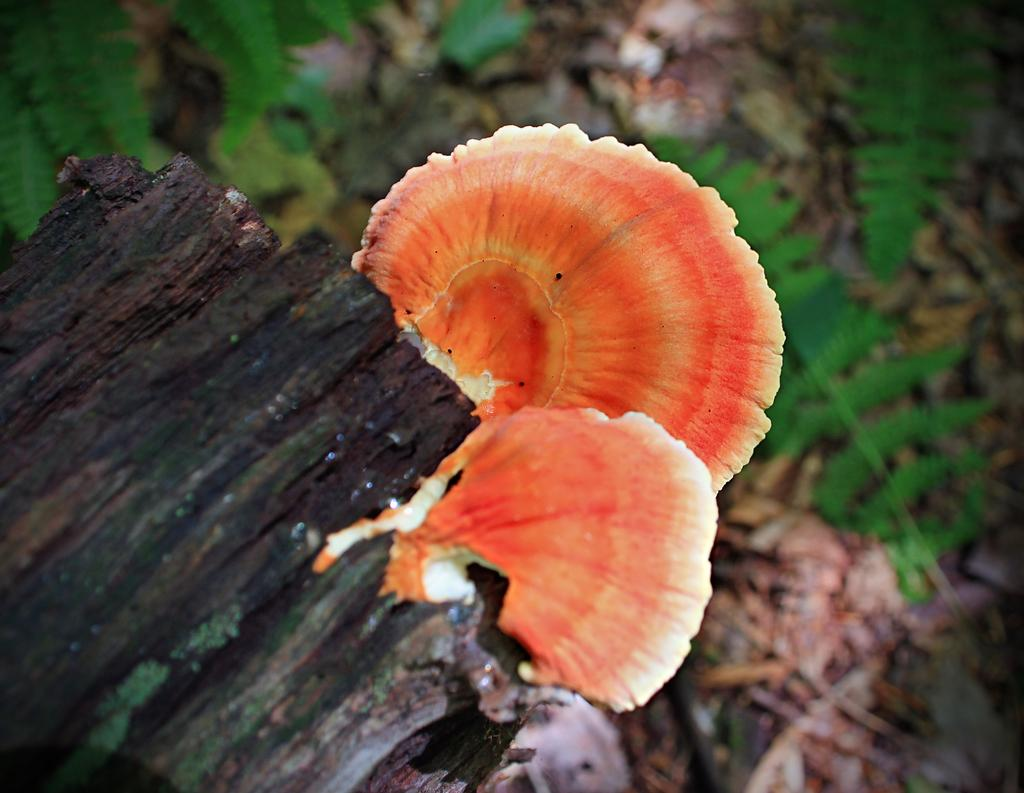What type of material is present in the image? There is a wooden material in the image. What is growing on the wooden material? There are mushrooms on the wooden material. What can be seen behind the wooden material? There are leaves visible behind the wooden material. Can you hear the sound of a bell in the image? There is no bell present in the image, so it is not possible to hear its sound. What type of river is flowing through the image? There is no river present in the image. 